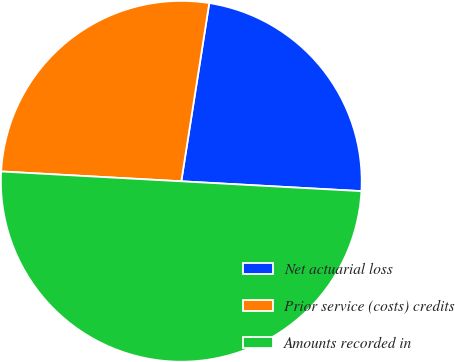Convert chart. <chart><loc_0><loc_0><loc_500><loc_500><pie_chart><fcel>Net actuarial loss<fcel>Prior service (costs) credits<fcel>Amounts recorded in<nl><fcel>23.39%<fcel>26.61%<fcel>50.0%<nl></chart> 